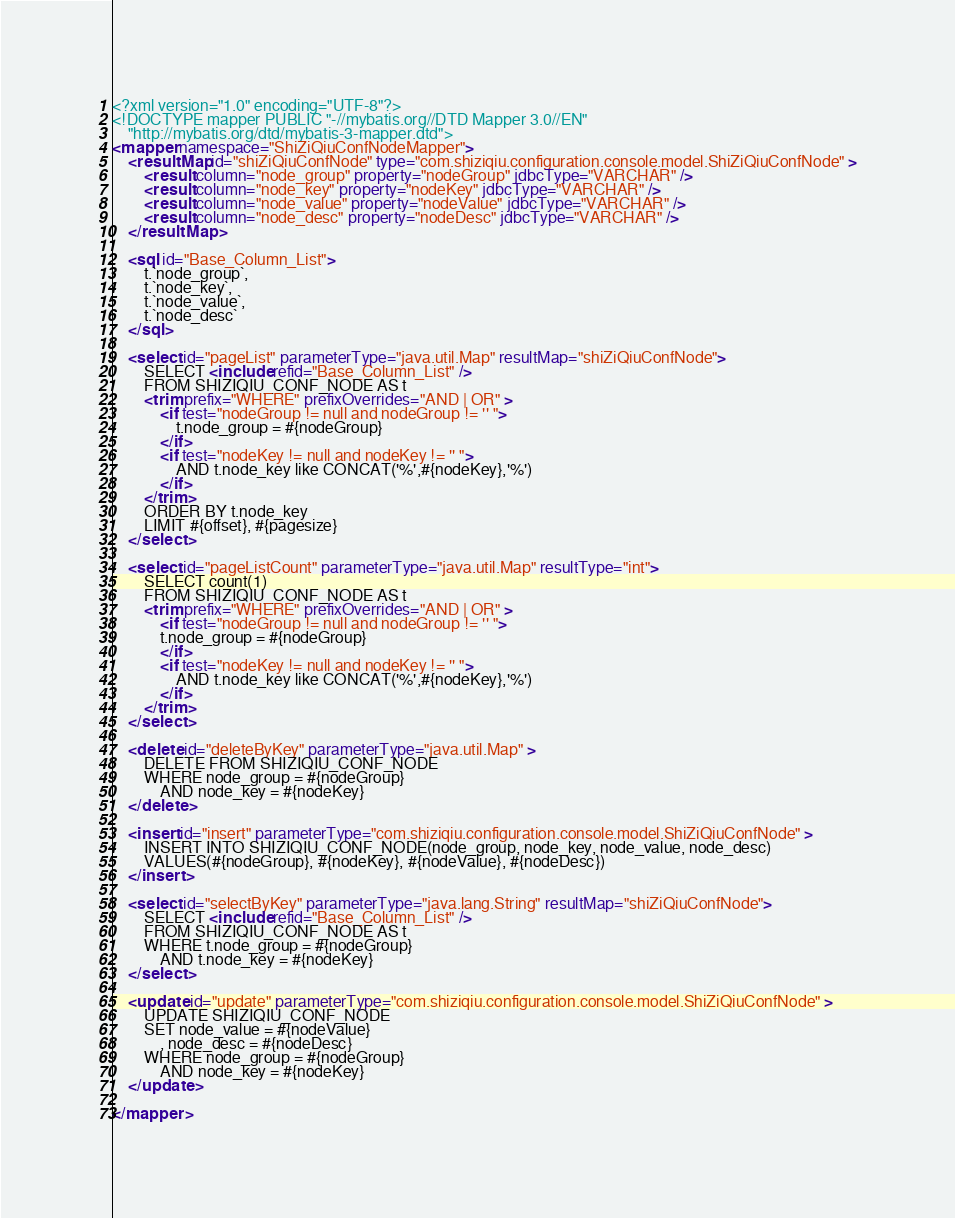Convert code to text. <code><loc_0><loc_0><loc_500><loc_500><_XML_><?xml version="1.0" encoding="UTF-8"?>
<!DOCTYPE mapper PUBLIC "-//mybatis.org//DTD Mapper 3.0//EN" 
	"http://mybatis.org/dtd/mybatis-3-mapper.dtd">
<mapper namespace="ShiZiQiuConfNodeMapper">
	<resultMap id="shiZiQiuConfNode" type="com.shiziqiu.configuration.console.model.ShiZiQiuConfNode" >
		<result column="node_group" property="nodeGroup" jdbcType="VARCHAR" />
		<result column="node_key" property="nodeKey" jdbcType="VARCHAR" />
	    <result column="node_value" property="nodeValue" jdbcType="VARCHAR" />
	    <result column="node_desc" property="nodeDesc" jdbcType="VARCHAR" />
	</resultMap>

	<sql id="Base_Column_List">
		t.`node_group`,
		t.`node_key`,
		t.`node_value`,
		t.`node_desc`
	</sql>

	<select id="pageList" parameterType="java.util.Map" resultMap="shiZiQiuConfNode">
		SELECT <include refid="Base_Column_List" />
		FROM SHIZIQIU_CONF_NODE AS t
		<trim prefix="WHERE" prefixOverrides="AND | OR" >
			<if test="nodeGroup != null and nodeGroup != '' ">
				t.node_group = #{nodeGroup}
			</if>
			<if test="nodeKey != null and nodeKey != '' ">
				AND t.node_key like CONCAT('%',#{nodeKey},'%')
			</if>
		</trim>
		ORDER BY t.node_key
		LIMIT #{offset}, #{pagesize}
	</select>

	<select id="pageListCount" parameterType="java.util.Map" resultType="int">
		SELECT count(1)
		FROM SHIZIQIU_CONF_NODE AS t
		<trim prefix="WHERE" prefixOverrides="AND | OR" >
			<if test="nodeGroup != null and nodeGroup != '' ">
			t.node_group = #{nodeGroup}
			</if>
			<if test="nodeKey != null and nodeKey != '' ">
				AND t.node_key like CONCAT('%',#{nodeKey},'%')
			</if>
		</trim>
	</select>

	<delete id="deleteByKey" parameterType="java.util.Map" >
		DELETE FROM SHIZIQIU_CONF_NODE
		WHERE node_group = #{nodeGroup}
			AND node_key = #{nodeKey}
	</delete>
	
	<insert id="insert" parameterType="com.shiziqiu.configuration.console.model.ShiZiQiuConfNode" >
		INSERT INTO SHIZIQIU_CONF_NODE(node_group, node_key, node_value, node_desc)
		VALUES(#{nodeGroup}, #{nodeKey}, #{nodeValue}, #{nodeDesc})
	</insert>
	
	<select id="selectByKey" parameterType="java.lang.String" resultMap="shiZiQiuConfNode">
		SELECT <include refid="Base_Column_List" />
		FROM SHIZIQIU_CONF_NODE AS t
		WHERE t.node_group = #{nodeGroup}
			AND t.node_key = #{nodeKey}
	</select>
	
	<update id="update" parameterType="com.shiziqiu.configuration.console.model.ShiZiQiuConfNode" >
		UPDATE SHIZIQIU_CONF_NODE 
		SET node_value = #{nodeValue}
			, node_desc = #{nodeDesc}
		WHERE node_group = #{nodeGroup}
			AND node_key = #{nodeKey}
	</update>
	
</mapper></code> 